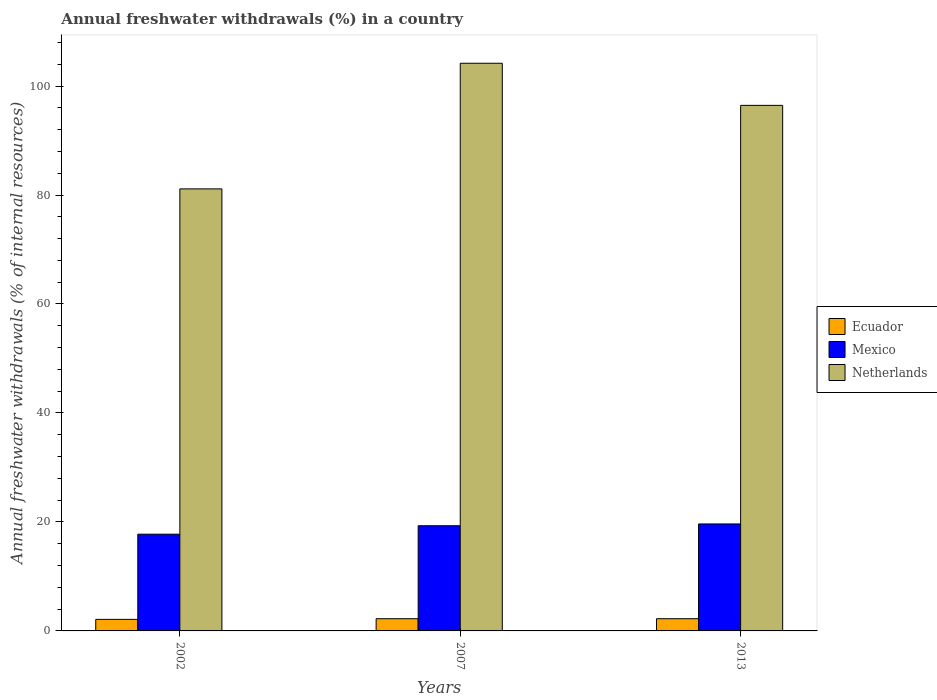How many different coloured bars are there?
Your response must be concise. 3. How many groups of bars are there?
Your answer should be very brief. 3. Are the number of bars per tick equal to the number of legend labels?
Your answer should be very brief. Yes. How many bars are there on the 2nd tick from the left?
Your answer should be compact. 3. What is the percentage of annual freshwater withdrawals in Ecuador in 2007?
Offer a very short reply. 2.24. Across all years, what is the maximum percentage of annual freshwater withdrawals in Ecuador?
Your answer should be very brief. 2.24. Across all years, what is the minimum percentage of annual freshwater withdrawals in Netherlands?
Keep it short and to the point. 81.13. In which year was the percentage of annual freshwater withdrawals in Ecuador minimum?
Give a very brief answer. 2002. What is the total percentage of annual freshwater withdrawals in Ecuador in the graph?
Keep it short and to the point. 6.6. What is the difference between the percentage of annual freshwater withdrawals in Mexico in 2007 and that in 2013?
Your answer should be compact. -0.33. What is the difference between the percentage of annual freshwater withdrawals in Mexico in 2007 and the percentage of annual freshwater withdrawals in Ecuador in 2002?
Provide a short and direct response. 17.19. What is the average percentage of annual freshwater withdrawals in Ecuador per year?
Keep it short and to the point. 2.2. In the year 2007, what is the difference between the percentage of annual freshwater withdrawals in Mexico and percentage of annual freshwater withdrawals in Ecuador?
Make the answer very short. 17.06. In how many years, is the percentage of annual freshwater withdrawals in Ecuador greater than 20 %?
Your answer should be compact. 0. What is the ratio of the percentage of annual freshwater withdrawals in Netherlands in 2007 to that in 2013?
Provide a short and direct response. 1.08. What is the difference between the highest and the second highest percentage of annual freshwater withdrawals in Netherlands?
Your answer should be very brief. 7.73. What is the difference between the highest and the lowest percentage of annual freshwater withdrawals in Ecuador?
Make the answer very short. 0.12. What does the 3rd bar from the left in 2007 represents?
Make the answer very short. Netherlands. What does the 3rd bar from the right in 2013 represents?
Offer a very short reply. Ecuador. Is it the case that in every year, the sum of the percentage of annual freshwater withdrawals in Mexico and percentage of annual freshwater withdrawals in Ecuador is greater than the percentage of annual freshwater withdrawals in Netherlands?
Make the answer very short. No. How many years are there in the graph?
Your response must be concise. 3. Where does the legend appear in the graph?
Ensure brevity in your answer.  Center right. How are the legend labels stacked?
Keep it short and to the point. Vertical. What is the title of the graph?
Offer a very short reply. Annual freshwater withdrawals (%) in a country. What is the label or title of the X-axis?
Offer a terse response. Years. What is the label or title of the Y-axis?
Your answer should be very brief. Annual freshwater withdrawals (% of internal resources). What is the Annual freshwater withdrawals (% of internal resources) of Ecuador in 2002?
Offer a terse response. 2.12. What is the Annual freshwater withdrawals (% of internal resources) of Mexico in 2002?
Your answer should be very brief. 17.75. What is the Annual freshwater withdrawals (% of internal resources) in Netherlands in 2002?
Make the answer very short. 81.13. What is the Annual freshwater withdrawals (% of internal resources) of Ecuador in 2007?
Your response must be concise. 2.24. What is the Annual freshwater withdrawals (% of internal resources) of Mexico in 2007?
Your answer should be compact. 19.3. What is the Annual freshwater withdrawals (% of internal resources) of Netherlands in 2007?
Make the answer very short. 104.18. What is the Annual freshwater withdrawals (% of internal resources) in Ecuador in 2013?
Make the answer very short. 2.24. What is the Annual freshwater withdrawals (% of internal resources) of Mexico in 2013?
Ensure brevity in your answer.  19.63. What is the Annual freshwater withdrawals (% of internal resources) of Netherlands in 2013?
Make the answer very short. 96.45. Across all years, what is the maximum Annual freshwater withdrawals (% of internal resources) in Ecuador?
Offer a very short reply. 2.24. Across all years, what is the maximum Annual freshwater withdrawals (% of internal resources) of Mexico?
Give a very brief answer. 19.63. Across all years, what is the maximum Annual freshwater withdrawals (% of internal resources) of Netherlands?
Your answer should be very brief. 104.18. Across all years, what is the minimum Annual freshwater withdrawals (% of internal resources) of Ecuador?
Offer a terse response. 2.12. Across all years, what is the minimum Annual freshwater withdrawals (% of internal resources) of Mexico?
Give a very brief answer. 17.75. Across all years, what is the minimum Annual freshwater withdrawals (% of internal resources) of Netherlands?
Offer a very short reply. 81.13. What is the total Annual freshwater withdrawals (% of internal resources) in Ecuador in the graph?
Your response must be concise. 6.6. What is the total Annual freshwater withdrawals (% of internal resources) in Mexico in the graph?
Ensure brevity in your answer.  56.69. What is the total Annual freshwater withdrawals (% of internal resources) in Netherlands in the graph?
Provide a short and direct response. 281.76. What is the difference between the Annual freshwater withdrawals (% of internal resources) of Ecuador in 2002 and that in 2007?
Keep it short and to the point. -0.12. What is the difference between the Annual freshwater withdrawals (% of internal resources) of Mexico in 2002 and that in 2007?
Your answer should be compact. -1.55. What is the difference between the Annual freshwater withdrawals (% of internal resources) of Netherlands in 2002 and that in 2007?
Keep it short and to the point. -23.05. What is the difference between the Annual freshwater withdrawals (% of internal resources) of Ecuador in 2002 and that in 2013?
Your answer should be compact. -0.12. What is the difference between the Annual freshwater withdrawals (% of internal resources) in Mexico in 2002 and that in 2013?
Offer a very short reply. -1.88. What is the difference between the Annual freshwater withdrawals (% of internal resources) in Netherlands in 2002 and that in 2013?
Make the answer very short. -15.33. What is the difference between the Annual freshwater withdrawals (% of internal resources) of Mexico in 2007 and that in 2013?
Keep it short and to the point. -0.33. What is the difference between the Annual freshwater withdrawals (% of internal resources) in Netherlands in 2007 and that in 2013?
Provide a short and direct response. 7.73. What is the difference between the Annual freshwater withdrawals (% of internal resources) of Ecuador in 2002 and the Annual freshwater withdrawals (% of internal resources) of Mexico in 2007?
Your answer should be compact. -17.19. What is the difference between the Annual freshwater withdrawals (% of internal resources) of Ecuador in 2002 and the Annual freshwater withdrawals (% of internal resources) of Netherlands in 2007?
Your response must be concise. -102.06. What is the difference between the Annual freshwater withdrawals (% of internal resources) of Mexico in 2002 and the Annual freshwater withdrawals (% of internal resources) of Netherlands in 2007?
Your answer should be compact. -86.43. What is the difference between the Annual freshwater withdrawals (% of internal resources) in Ecuador in 2002 and the Annual freshwater withdrawals (% of internal resources) in Mexico in 2013?
Provide a succinct answer. -17.52. What is the difference between the Annual freshwater withdrawals (% of internal resources) in Ecuador in 2002 and the Annual freshwater withdrawals (% of internal resources) in Netherlands in 2013?
Offer a terse response. -94.34. What is the difference between the Annual freshwater withdrawals (% of internal resources) in Mexico in 2002 and the Annual freshwater withdrawals (% of internal resources) in Netherlands in 2013?
Give a very brief answer. -78.7. What is the difference between the Annual freshwater withdrawals (% of internal resources) in Ecuador in 2007 and the Annual freshwater withdrawals (% of internal resources) in Mexico in 2013?
Your response must be concise. -17.39. What is the difference between the Annual freshwater withdrawals (% of internal resources) in Ecuador in 2007 and the Annual freshwater withdrawals (% of internal resources) in Netherlands in 2013?
Make the answer very short. -94.21. What is the difference between the Annual freshwater withdrawals (% of internal resources) of Mexico in 2007 and the Annual freshwater withdrawals (% of internal resources) of Netherlands in 2013?
Offer a terse response. -77.15. What is the average Annual freshwater withdrawals (% of internal resources) in Ecuador per year?
Offer a terse response. 2.2. What is the average Annual freshwater withdrawals (% of internal resources) in Mexico per year?
Your answer should be compact. 18.9. What is the average Annual freshwater withdrawals (% of internal resources) in Netherlands per year?
Give a very brief answer. 93.92. In the year 2002, what is the difference between the Annual freshwater withdrawals (% of internal resources) of Ecuador and Annual freshwater withdrawals (% of internal resources) of Mexico?
Your answer should be very brief. -15.63. In the year 2002, what is the difference between the Annual freshwater withdrawals (% of internal resources) of Ecuador and Annual freshwater withdrawals (% of internal resources) of Netherlands?
Provide a short and direct response. -79.01. In the year 2002, what is the difference between the Annual freshwater withdrawals (% of internal resources) of Mexico and Annual freshwater withdrawals (% of internal resources) of Netherlands?
Offer a very short reply. -63.38. In the year 2007, what is the difference between the Annual freshwater withdrawals (% of internal resources) of Ecuador and Annual freshwater withdrawals (% of internal resources) of Mexico?
Offer a terse response. -17.06. In the year 2007, what is the difference between the Annual freshwater withdrawals (% of internal resources) in Ecuador and Annual freshwater withdrawals (% of internal resources) in Netherlands?
Make the answer very short. -101.94. In the year 2007, what is the difference between the Annual freshwater withdrawals (% of internal resources) in Mexico and Annual freshwater withdrawals (% of internal resources) in Netherlands?
Offer a terse response. -84.88. In the year 2013, what is the difference between the Annual freshwater withdrawals (% of internal resources) of Ecuador and Annual freshwater withdrawals (% of internal resources) of Mexico?
Offer a terse response. -17.39. In the year 2013, what is the difference between the Annual freshwater withdrawals (% of internal resources) of Ecuador and Annual freshwater withdrawals (% of internal resources) of Netherlands?
Your response must be concise. -94.21. In the year 2013, what is the difference between the Annual freshwater withdrawals (% of internal resources) in Mexico and Annual freshwater withdrawals (% of internal resources) in Netherlands?
Provide a succinct answer. -76.82. What is the ratio of the Annual freshwater withdrawals (% of internal resources) in Ecuador in 2002 to that in 2007?
Your answer should be very brief. 0.94. What is the ratio of the Annual freshwater withdrawals (% of internal resources) of Mexico in 2002 to that in 2007?
Offer a terse response. 0.92. What is the ratio of the Annual freshwater withdrawals (% of internal resources) of Netherlands in 2002 to that in 2007?
Offer a terse response. 0.78. What is the ratio of the Annual freshwater withdrawals (% of internal resources) of Ecuador in 2002 to that in 2013?
Offer a very short reply. 0.94. What is the ratio of the Annual freshwater withdrawals (% of internal resources) in Mexico in 2002 to that in 2013?
Keep it short and to the point. 0.9. What is the ratio of the Annual freshwater withdrawals (% of internal resources) of Netherlands in 2002 to that in 2013?
Offer a terse response. 0.84. What is the ratio of the Annual freshwater withdrawals (% of internal resources) in Ecuador in 2007 to that in 2013?
Make the answer very short. 1. What is the ratio of the Annual freshwater withdrawals (% of internal resources) of Mexico in 2007 to that in 2013?
Keep it short and to the point. 0.98. What is the ratio of the Annual freshwater withdrawals (% of internal resources) of Netherlands in 2007 to that in 2013?
Offer a terse response. 1.08. What is the difference between the highest and the second highest Annual freshwater withdrawals (% of internal resources) of Mexico?
Offer a terse response. 0.33. What is the difference between the highest and the second highest Annual freshwater withdrawals (% of internal resources) in Netherlands?
Ensure brevity in your answer.  7.73. What is the difference between the highest and the lowest Annual freshwater withdrawals (% of internal resources) of Ecuador?
Provide a succinct answer. 0.12. What is the difference between the highest and the lowest Annual freshwater withdrawals (% of internal resources) of Mexico?
Your answer should be very brief. 1.88. What is the difference between the highest and the lowest Annual freshwater withdrawals (% of internal resources) of Netherlands?
Your answer should be compact. 23.05. 